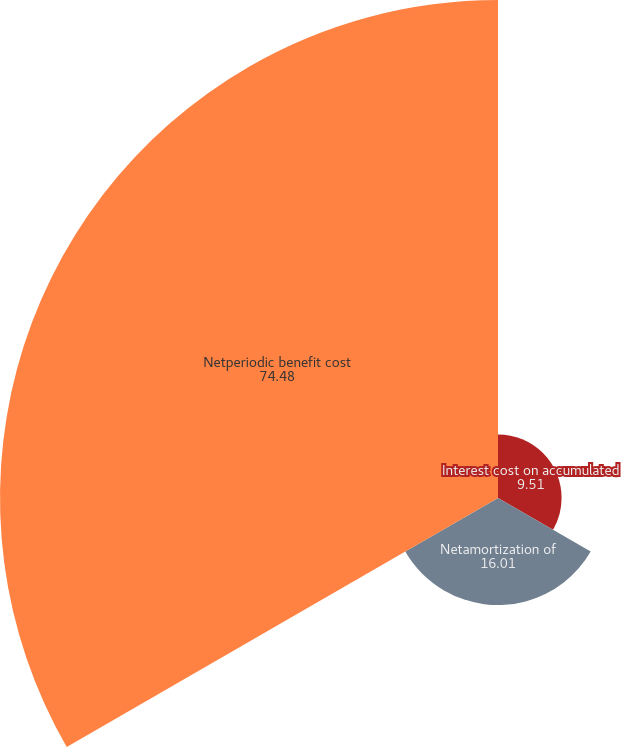Convert chart. <chart><loc_0><loc_0><loc_500><loc_500><pie_chart><fcel>Interest cost on accumulated<fcel>Netamortization of<fcel>Netperiodic benefit cost<nl><fcel>9.51%<fcel>16.01%<fcel>74.48%<nl></chart> 